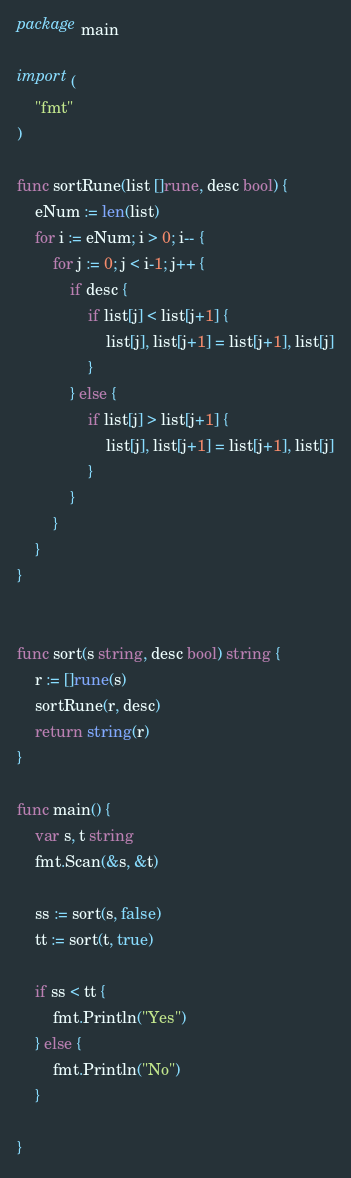Convert code to text. <code><loc_0><loc_0><loc_500><loc_500><_Go_>package main

import (
	"fmt"
)

func sortRune(list []rune, desc bool) {
	eNum := len(list)
	for i := eNum; i > 0; i-- {
		for j := 0; j < i-1; j++ {
			if desc {
				if list[j] < list[j+1] {
					list[j], list[j+1] = list[j+1], list[j]
				}
			} else {
				if list[j] > list[j+1] {
					list[j], list[j+1] = list[j+1], list[j]
				}
			}
		}
	}
}


func sort(s string, desc bool) string {
	r := []rune(s)
	sortRune(r, desc)
	return string(r)
}

func main() {
	var s, t string
	fmt.Scan(&s, &t)

	ss := sort(s, false)
	tt := sort(t, true)

	if ss < tt {
		fmt.Println("Yes")
	} else {
		fmt.Println("No")
	}

}</code> 